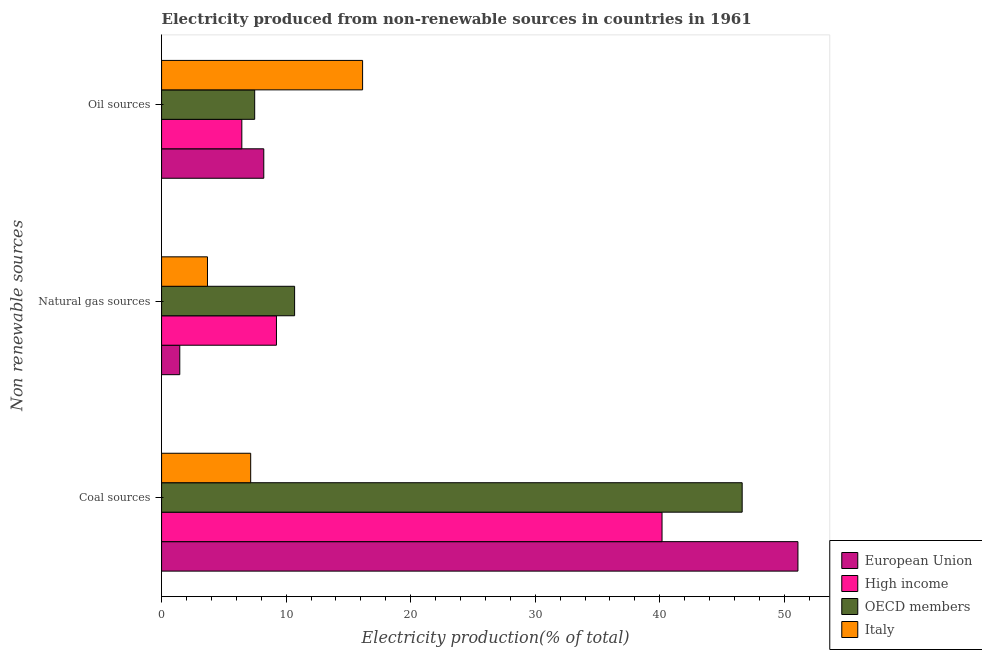How many groups of bars are there?
Provide a short and direct response. 3. How many bars are there on the 2nd tick from the top?
Keep it short and to the point. 4. What is the label of the 2nd group of bars from the top?
Offer a very short reply. Natural gas sources. What is the percentage of electricity produced by oil sources in Italy?
Your answer should be compact. 16.14. Across all countries, what is the maximum percentage of electricity produced by coal?
Provide a succinct answer. 51.09. Across all countries, what is the minimum percentage of electricity produced by oil sources?
Provide a short and direct response. 6.44. In which country was the percentage of electricity produced by oil sources minimum?
Provide a short and direct response. High income. What is the total percentage of electricity produced by natural gas in the graph?
Offer a very short reply. 25.05. What is the difference between the percentage of electricity produced by natural gas in High income and that in OECD members?
Provide a short and direct response. -1.46. What is the difference between the percentage of electricity produced by oil sources in OECD members and the percentage of electricity produced by coal in High income?
Your answer should be very brief. -32.71. What is the average percentage of electricity produced by oil sources per country?
Offer a very short reply. 9.57. What is the difference between the percentage of electricity produced by coal and percentage of electricity produced by oil sources in Italy?
Provide a succinct answer. -8.98. What is the ratio of the percentage of electricity produced by oil sources in OECD members to that in Italy?
Your response must be concise. 0.46. Is the percentage of electricity produced by coal in European Union less than that in Italy?
Give a very brief answer. No. Is the difference between the percentage of electricity produced by coal in European Union and High income greater than the difference between the percentage of electricity produced by natural gas in European Union and High income?
Provide a succinct answer. Yes. What is the difference between the highest and the second highest percentage of electricity produced by natural gas?
Ensure brevity in your answer.  1.46. What is the difference between the highest and the lowest percentage of electricity produced by oil sources?
Make the answer very short. 9.7. What does the 2nd bar from the top in Coal sources represents?
Offer a very short reply. OECD members. How many countries are there in the graph?
Offer a terse response. 4. What is the difference between two consecutive major ticks on the X-axis?
Your answer should be very brief. 10. Does the graph contain any zero values?
Provide a succinct answer. No. Where does the legend appear in the graph?
Your answer should be compact. Bottom right. How many legend labels are there?
Your response must be concise. 4. What is the title of the graph?
Ensure brevity in your answer.  Electricity produced from non-renewable sources in countries in 1961. What is the label or title of the X-axis?
Give a very brief answer. Electricity production(% of total). What is the label or title of the Y-axis?
Ensure brevity in your answer.  Non renewable sources. What is the Electricity production(% of total) in European Union in Coal sources?
Keep it short and to the point. 51.09. What is the Electricity production(% of total) in High income in Coal sources?
Your response must be concise. 40.18. What is the Electricity production(% of total) of OECD members in Coal sources?
Keep it short and to the point. 46.61. What is the Electricity production(% of total) of Italy in Coal sources?
Provide a short and direct response. 7.15. What is the Electricity production(% of total) of European Union in Natural gas sources?
Give a very brief answer. 1.46. What is the Electricity production(% of total) of High income in Natural gas sources?
Offer a very short reply. 9.22. What is the Electricity production(% of total) in OECD members in Natural gas sources?
Provide a short and direct response. 10.68. What is the Electricity production(% of total) in Italy in Natural gas sources?
Your response must be concise. 3.69. What is the Electricity production(% of total) of European Union in Oil sources?
Your answer should be very brief. 8.21. What is the Electricity production(% of total) of High income in Oil sources?
Make the answer very short. 6.44. What is the Electricity production(% of total) of OECD members in Oil sources?
Make the answer very short. 7.48. What is the Electricity production(% of total) in Italy in Oil sources?
Your response must be concise. 16.14. Across all Non renewable sources, what is the maximum Electricity production(% of total) of European Union?
Offer a very short reply. 51.09. Across all Non renewable sources, what is the maximum Electricity production(% of total) in High income?
Keep it short and to the point. 40.18. Across all Non renewable sources, what is the maximum Electricity production(% of total) in OECD members?
Provide a succinct answer. 46.61. Across all Non renewable sources, what is the maximum Electricity production(% of total) in Italy?
Give a very brief answer. 16.14. Across all Non renewable sources, what is the minimum Electricity production(% of total) in European Union?
Your response must be concise. 1.46. Across all Non renewable sources, what is the minimum Electricity production(% of total) in High income?
Give a very brief answer. 6.44. Across all Non renewable sources, what is the minimum Electricity production(% of total) of OECD members?
Offer a terse response. 7.48. Across all Non renewable sources, what is the minimum Electricity production(% of total) in Italy?
Your answer should be very brief. 3.69. What is the total Electricity production(% of total) in European Union in the graph?
Your answer should be compact. 60.76. What is the total Electricity production(% of total) of High income in the graph?
Give a very brief answer. 55.85. What is the total Electricity production(% of total) of OECD members in the graph?
Provide a succinct answer. 64.77. What is the total Electricity production(% of total) of Italy in the graph?
Provide a succinct answer. 26.98. What is the difference between the Electricity production(% of total) in European Union in Coal sources and that in Natural gas sources?
Make the answer very short. 49.63. What is the difference between the Electricity production(% of total) in High income in Coal sources and that in Natural gas sources?
Offer a terse response. 30.96. What is the difference between the Electricity production(% of total) of OECD members in Coal sources and that in Natural gas sources?
Offer a terse response. 35.93. What is the difference between the Electricity production(% of total) of Italy in Coal sources and that in Natural gas sources?
Your response must be concise. 3.47. What is the difference between the Electricity production(% of total) of European Union in Coal sources and that in Oil sources?
Keep it short and to the point. 42.89. What is the difference between the Electricity production(% of total) in High income in Coal sources and that in Oil sources?
Your answer should be very brief. 33.74. What is the difference between the Electricity production(% of total) in OECD members in Coal sources and that in Oil sources?
Ensure brevity in your answer.  39.14. What is the difference between the Electricity production(% of total) of Italy in Coal sources and that in Oil sources?
Offer a very short reply. -8.98. What is the difference between the Electricity production(% of total) of European Union in Natural gas sources and that in Oil sources?
Keep it short and to the point. -6.74. What is the difference between the Electricity production(% of total) of High income in Natural gas sources and that in Oil sources?
Provide a short and direct response. 2.78. What is the difference between the Electricity production(% of total) of OECD members in Natural gas sources and that in Oil sources?
Make the answer very short. 3.21. What is the difference between the Electricity production(% of total) of Italy in Natural gas sources and that in Oil sources?
Provide a short and direct response. -12.45. What is the difference between the Electricity production(% of total) of European Union in Coal sources and the Electricity production(% of total) of High income in Natural gas sources?
Make the answer very short. 41.87. What is the difference between the Electricity production(% of total) in European Union in Coal sources and the Electricity production(% of total) in OECD members in Natural gas sources?
Offer a terse response. 40.41. What is the difference between the Electricity production(% of total) of European Union in Coal sources and the Electricity production(% of total) of Italy in Natural gas sources?
Provide a succinct answer. 47.41. What is the difference between the Electricity production(% of total) in High income in Coal sources and the Electricity production(% of total) in OECD members in Natural gas sources?
Provide a short and direct response. 29.5. What is the difference between the Electricity production(% of total) in High income in Coal sources and the Electricity production(% of total) in Italy in Natural gas sources?
Provide a short and direct response. 36.49. What is the difference between the Electricity production(% of total) of OECD members in Coal sources and the Electricity production(% of total) of Italy in Natural gas sources?
Provide a succinct answer. 42.93. What is the difference between the Electricity production(% of total) in European Union in Coal sources and the Electricity production(% of total) in High income in Oil sources?
Make the answer very short. 44.65. What is the difference between the Electricity production(% of total) of European Union in Coal sources and the Electricity production(% of total) of OECD members in Oil sources?
Your answer should be compact. 43.62. What is the difference between the Electricity production(% of total) of European Union in Coal sources and the Electricity production(% of total) of Italy in Oil sources?
Give a very brief answer. 34.95. What is the difference between the Electricity production(% of total) in High income in Coal sources and the Electricity production(% of total) in OECD members in Oil sources?
Your answer should be very brief. 32.71. What is the difference between the Electricity production(% of total) in High income in Coal sources and the Electricity production(% of total) in Italy in Oil sources?
Provide a short and direct response. 24.04. What is the difference between the Electricity production(% of total) of OECD members in Coal sources and the Electricity production(% of total) of Italy in Oil sources?
Your answer should be very brief. 30.48. What is the difference between the Electricity production(% of total) in European Union in Natural gas sources and the Electricity production(% of total) in High income in Oil sources?
Give a very brief answer. -4.98. What is the difference between the Electricity production(% of total) of European Union in Natural gas sources and the Electricity production(% of total) of OECD members in Oil sources?
Offer a terse response. -6.01. What is the difference between the Electricity production(% of total) of European Union in Natural gas sources and the Electricity production(% of total) of Italy in Oil sources?
Ensure brevity in your answer.  -14.68. What is the difference between the Electricity production(% of total) in High income in Natural gas sources and the Electricity production(% of total) in OECD members in Oil sources?
Your answer should be very brief. 1.75. What is the difference between the Electricity production(% of total) of High income in Natural gas sources and the Electricity production(% of total) of Italy in Oil sources?
Your answer should be compact. -6.92. What is the difference between the Electricity production(% of total) in OECD members in Natural gas sources and the Electricity production(% of total) in Italy in Oil sources?
Your response must be concise. -5.46. What is the average Electricity production(% of total) in European Union per Non renewable sources?
Offer a terse response. 20.25. What is the average Electricity production(% of total) of High income per Non renewable sources?
Your answer should be very brief. 18.62. What is the average Electricity production(% of total) in OECD members per Non renewable sources?
Give a very brief answer. 21.59. What is the average Electricity production(% of total) of Italy per Non renewable sources?
Provide a succinct answer. 8.99. What is the difference between the Electricity production(% of total) of European Union and Electricity production(% of total) of High income in Coal sources?
Your answer should be compact. 10.91. What is the difference between the Electricity production(% of total) of European Union and Electricity production(% of total) of OECD members in Coal sources?
Provide a short and direct response. 4.48. What is the difference between the Electricity production(% of total) in European Union and Electricity production(% of total) in Italy in Coal sources?
Offer a very short reply. 43.94. What is the difference between the Electricity production(% of total) of High income and Electricity production(% of total) of OECD members in Coal sources?
Give a very brief answer. -6.43. What is the difference between the Electricity production(% of total) in High income and Electricity production(% of total) in Italy in Coal sources?
Offer a very short reply. 33.03. What is the difference between the Electricity production(% of total) in OECD members and Electricity production(% of total) in Italy in Coal sources?
Your response must be concise. 39.46. What is the difference between the Electricity production(% of total) of European Union and Electricity production(% of total) of High income in Natural gas sources?
Offer a terse response. -7.76. What is the difference between the Electricity production(% of total) in European Union and Electricity production(% of total) in OECD members in Natural gas sources?
Your response must be concise. -9.22. What is the difference between the Electricity production(% of total) in European Union and Electricity production(% of total) in Italy in Natural gas sources?
Keep it short and to the point. -2.22. What is the difference between the Electricity production(% of total) in High income and Electricity production(% of total) in OECD members in Natural gas sources?
Offer a terse response. -1.46. What is the difference between the Electricity production(% of total) in High income and Electricity production(% of total) in Italy in Natural gas sources?
Keep it short and to the point. 5.54. What is the difference between the Electricity production(% of total) in OECD members and Electricity production(% of total) in Italy in Natural gas sources?
Ensure brevity in your answer.  7. What is the difference between the Electricity production(% of total) of European Union and Electricity production(% of total) of High income in Oil sources?
Offer a terse response. 1.76. What is the difference between the Electricity production(% of total) of European Union and Electricity production(% of total) of OECD members in Oil sources?
Give a very brief answer. 0.73. What is the difference between the Electricity production(% of total) of European Union and Electricity production(% of total) of Italy in Oil sources?
Provide a short and direct response. -7.93. What is the difference between the Electricity production(% of total) in High income and Electricity production(% of total) in OECD members in Oil sources?
Offer a terse response. -1.03. What is the difference between the Electricity production(% of total) in High income and Electricity production(% of total) in Italy in Oil sources?
Your answer should be compact. -9.7. What is the difference between the Electricity production(% of total) in OECD members and Electricity production(% of total) in Italy in Oil sources?
Keep it short and to the point. -8.66. What is the ratio of the Electricity production(% of total) of European Union in Coal sources to that in Natural gas sources?
Your answer should be compact. 34.95. What is the ratio of the Electricity production(% of total) in High income in Coal sources to that in Natural gas sources?
Ensure brevity in your answer.  4.36. What is the ratio of the Electricity production(% of total) of OECD members in Coal sources to that in Natural gas sources?
Your response must be concise. 4.36. What is the ratio of the Electricity production(% of total) of Italy in Coal sources to that in Natural gas sources?
Provide a short and direct response. 1.94. What is the ratio of the Electricity production(% of total) of European Union in Coal sources to that in Oil sources?
Make the answer very short. 6.23. What is the ratio of the Electricity production(% of total) of High income in Coal sources to that in Oil sources?
Your response must be concise. 6.24. What is the ratio of the Electricity production(% of total) in OECD members in Coal sources to that in Oil sources?
Give a very brief answer. 6.24. What is the ratio of the Electricity production(% of total) of Italy in Coal sources to that in Oil sources?
Your answer should be very brief. 0.44. What is the ratio of the Electricity production(% of total) in European Union in Natural gas sources to that in Oil sources?
Your answer should be very brief. 0.18. What is the ratio of the Electricity production(% of total) in High income in Natural gas sources to that in Oil sources?
Ensure brevity in your answer.  1.43. What is the ratio of the Electricity production(% of total) of OECD members in Natural gas sources to that in Oil sources?
Offer a very short reply. 1.43. What is the ratio of the Electricity production(% of total) of Italy in Natural gas sources to that in Oil sources?
Keep it short and to the point. 0.23. What is the difference between the highest and the second highest Electricity production(% of total) of European Union?
Your answer should be compact. 42.89. What is the difference between the highest and the second highest Electricity production(% of total) of High income?
Give a very brief answer. 30.96. What is the difference between the highest and the second highest Electricity production(% of total) in OECD members?
Provide a succinct answer. 35.93. What is the difference between the highest and the second highest Electricity production(% of total) in Italy?
Offer a very short reply. 8.98. What is the difference between the highest and the lowest Electricity production(% of total) in European Union?
Your answer should be very brief. 49.63. What is the difference between the highest and the lowest Electricity production(% of total) in High income?
Keep it short and to the point. 33.74. What is the difference between the highest and the lowest Electricity production(% of total) in OECD members?
Your answer should be compact. 39.14. What is the difference between the highest and the lowest Electricity production(% of total) of Italy?
Offer a very short reply. 12.45. 